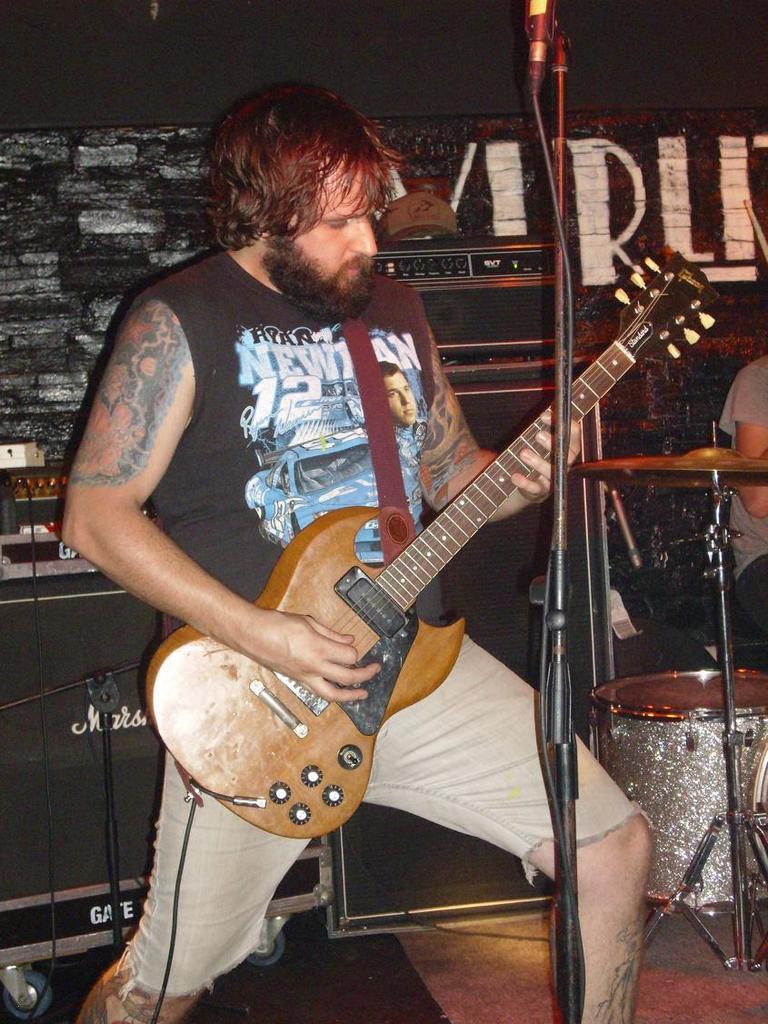In one or two sentences, can you explain what this image depicts? This picture is of inside. On the right we can see a drum, a microphone attached to the stand and a person sitting on the chair. In the center there is a man wearing black color t-shirt, playing guitar and standing. In the background we can see the musical instruments, a banner and a wall. 